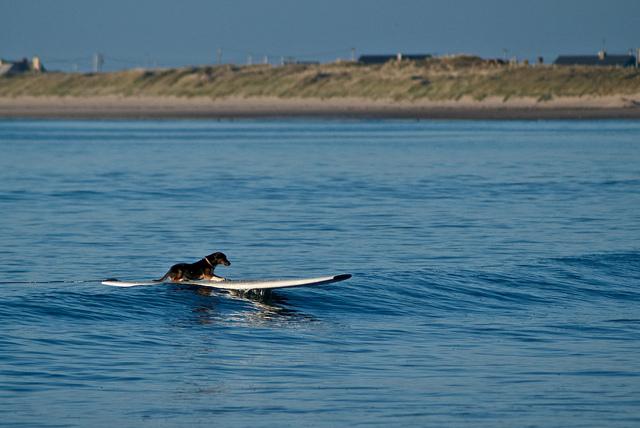What is the dog riding on?
Short answer required. Surfboard. Is the dog wearing a collar?
Quick response, please. Yes. Is it a clear day?
Concise answer only. Yes. Is there a body of water here?
Write a very short answer. Yes. What is in the water?
Keep it brief. Dog on surfboard. 